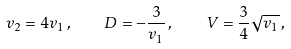<formula> <loc_0><loc_0><loc_500><loc_500>v _ { 2 } = 4 v _ { 1 } \, , \quad D = - \frac { 3 } { v _ { 1 } } \, , \quad V = \frac { 3 } { 4 } \sqrt { v _ { 1 } } \, ,</formula> 